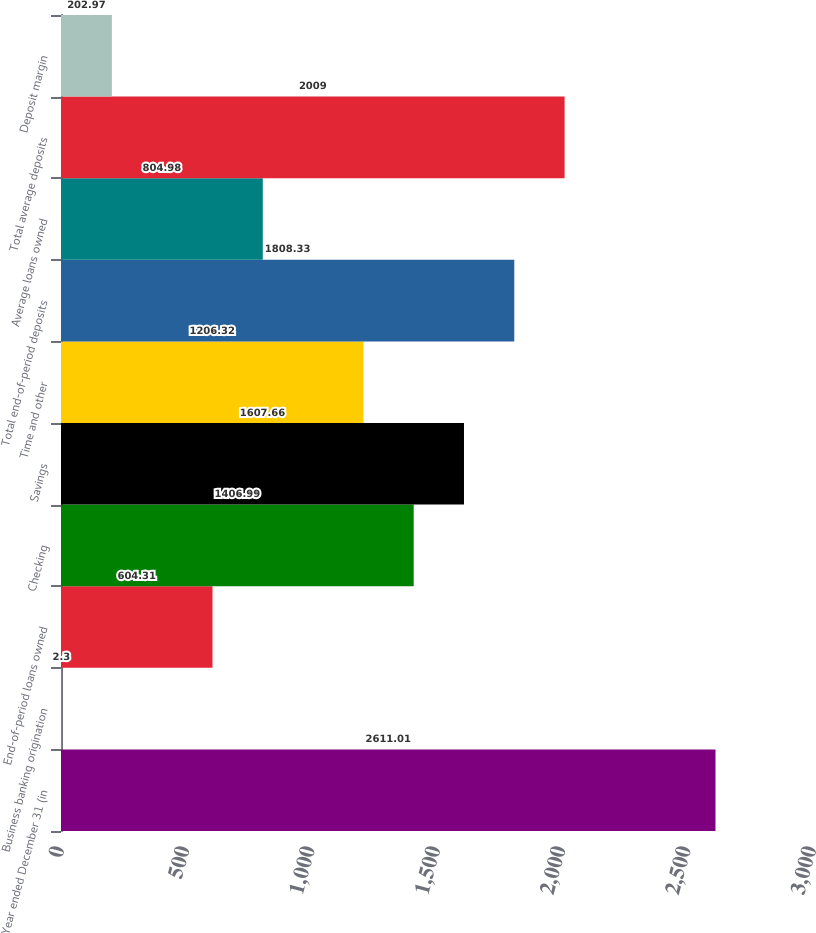Convert chart to OTSL. <chart><loc_0><loc_0><loc_500><loc_500><bar_chart><fcel>Year ended December 31 (in<fcel>Business banking origination<fcel>End-of-period loans owned<fcel>Checking<fcel>Savings<fcel>Time and other<fcel>Total end-of-period deposits<fcel>Average loans owned<fcel>Total average deposits<fcel>Deposit margin<nl><fcel>2611.01<fcel>2.3<fcel>604.31<fcel>1406.99<fcel>1607.66<fcel>1206.32<fcel>1808.33<fcel>804.98<fcel>2009<fcel>202.97<nl></chart> 